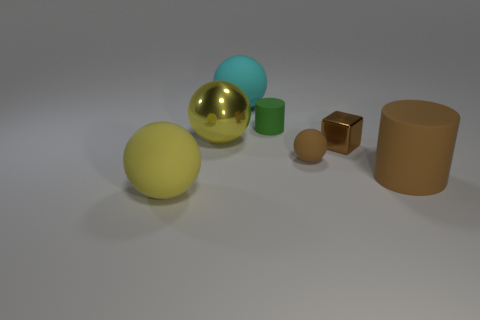Add 2 cylinders. How many objects exist? 9 Subtract all green spheres. Subtract all cyan blocks. How many spheres are left? 4 Subtract all balls. How many objects are left? 3 Subtract all tiny green things. Subtract all big metallic objects. How many objects are left? 5 Add 5 large yellow things. How many large yellow things are left? 7 Add 5 big red metallic blocks. How many big red metallic blocks exist? 5 Subtract 0 blue balls. How many objects are left? 7 